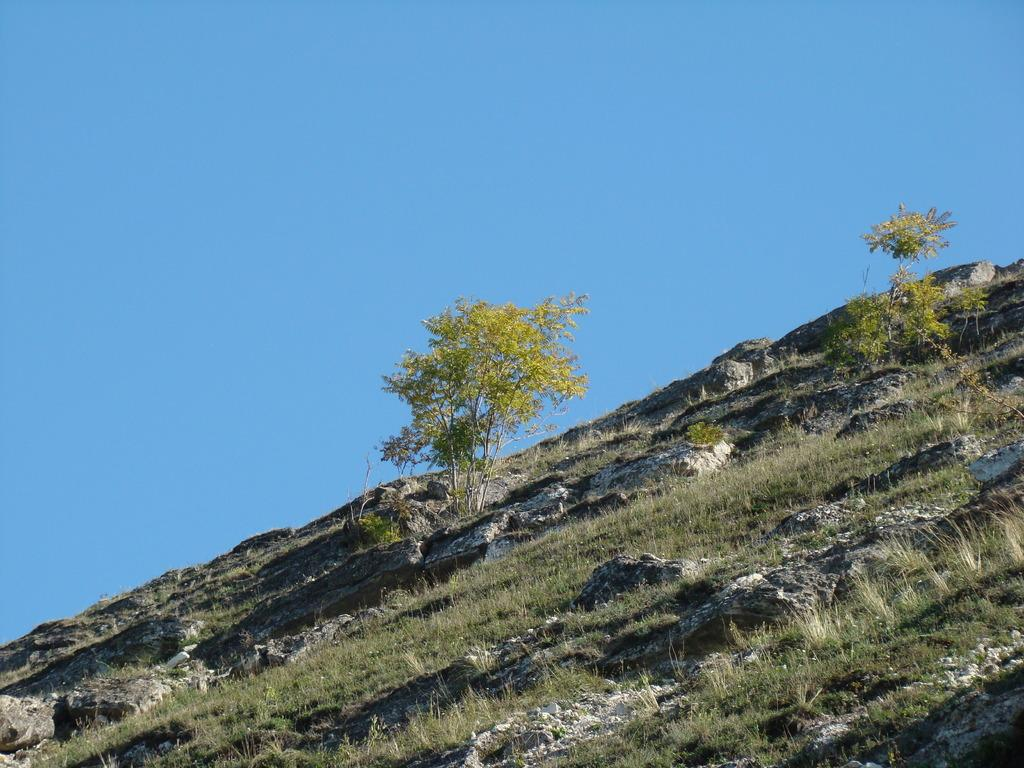Where was the image taken? The image was clicked outside. What can be seen in the middle of the image? There is grass and trees in the middle of the image. What is visible at the top of the image? The sky is visible at the top of the image. How many grapes are hanging from the trees in the image? There are no grapes visible in the image; only grass and trees are present. What type of love can be seen expressed between the trees in the image? There is no expression of love between the trees in the image, as trees do not have the ability to express emotions. 